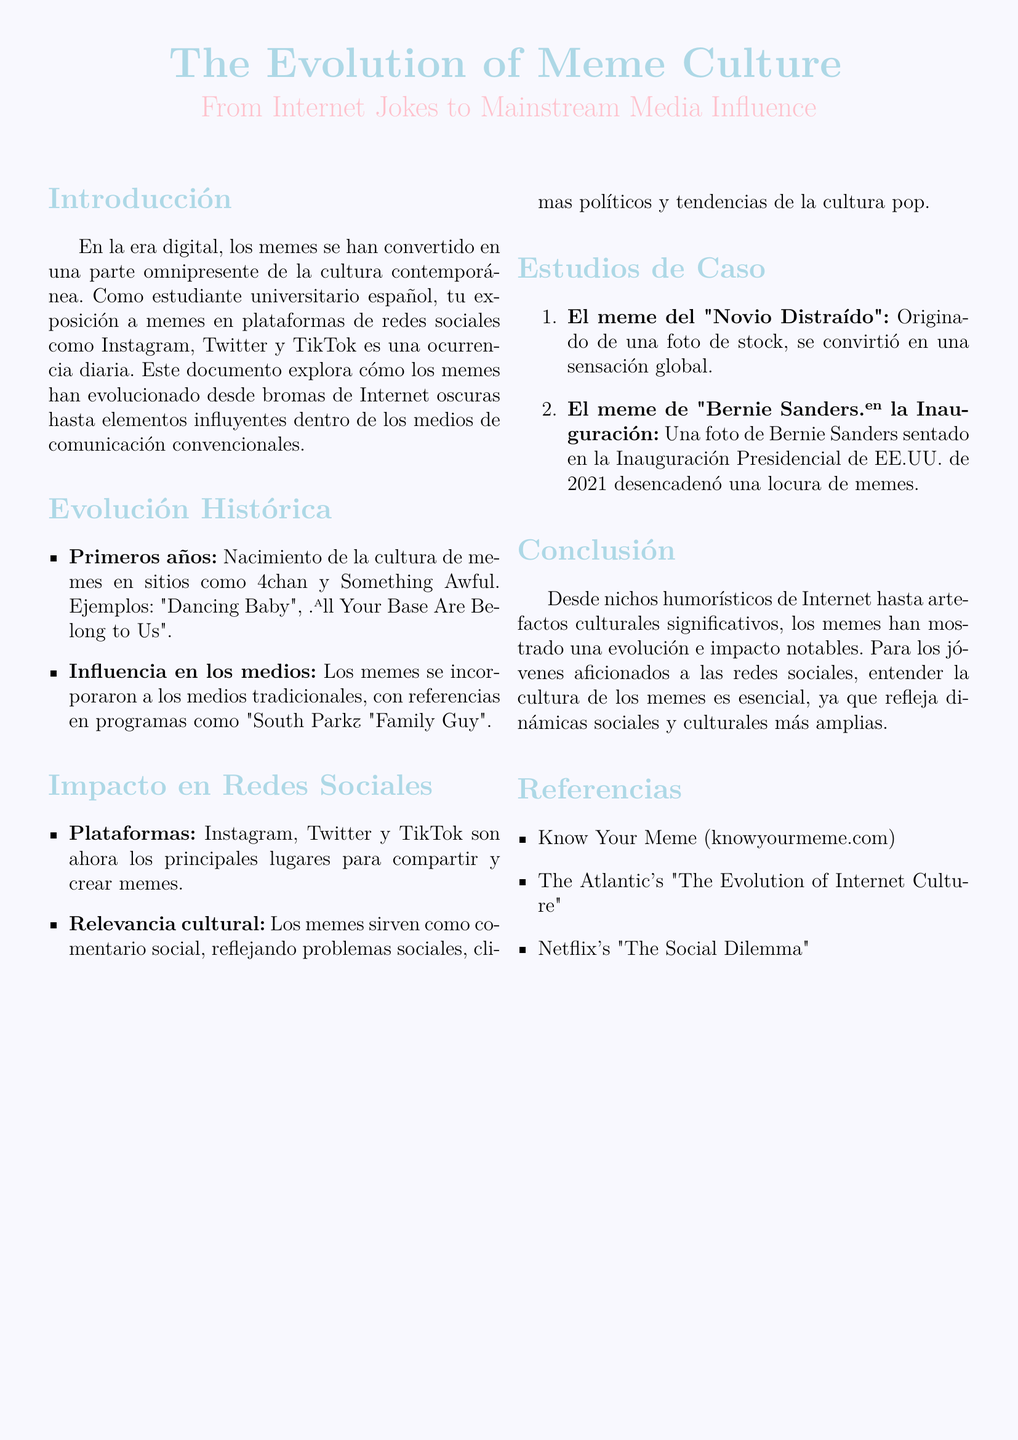¿Cuáles son las plataformas principales para compartir memes? Las principales plataformas mencionadas en el documento son Instagram, Twitter y TikTok.
Answer: Instagram, Twitter y TikTok ¿Cuál fue un ejemplo de meme de los primeros años? El documento menciona "Dancing Baby" y "All Your Base Are Belong to Us" como ejemplos de memes de los primeros años.
Answer: Dancing Baby ¿Qué impacto tienen los memes según el documento? Los memes sirven como comentario social, reflejando problemas sociales, climas políticos y tendencias de la cultura pop.
Answer: Comentario social ¿Cuál es un caso de estudio mencionado en el documento? El documento lista el meme del "Novio Distraído" y el meme de "Bernie Sanders" en la Inauguración como estudios de caso.
Answer: Novio Distraído ¿Cómo ha cambiado la percepción de los memes? En el documento, se señala que los memes han evolucionado de un nicho humorístico a artefactos culturales significativos.
Answer: Artefactos culturales significativos ¿Cuál es el tono del documento? El tono del documento es informativo y académico, ya que explora la evolución y el impacto de los memes.
Answer: Informativo y académico 